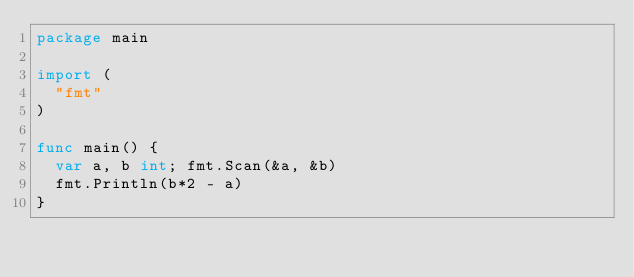<code> <loc_0><loc_0><loc_500><loc_500><_Go_>package main

import (
  "fmt"
)

func main() {
  var a, b int; fmt.Scan(&a, &b)
  fmt.Println(b*2 - a)
}</code> 